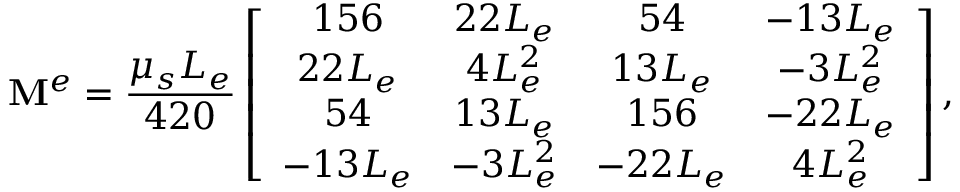Convert formula to latex. <formula><loc_0><loc_0><loc_500><loc_500>M ^ { e } = \frac { \mu _ { s } L _ { e } } { 4 2 0 } \left [ \begin{array} { c c c c } { 1 5 6 } & { 2 2 L _ { e } } & { 5 4 } & { - 1 3 L _ { e } } \\ { 2 2 L _ { e } } & { 4 L _ { e } ^ { 2 } } & { 1 3 L _ { e } } & { - 3 L _ { e } ^ { 2 } } \\ { 5 4 } & { 1 3 L _ { e } } & { 1 5 6 } & { - 2 2 L _ { e } } \\ { - 1 3 L _ { e } } & { - 3 L _ { e } ^ { 2 } } & { - 2 2 L _ { e } } & { 4 L _ { e } ^ { 2 } } \end{array} \right ] ,</formula> 